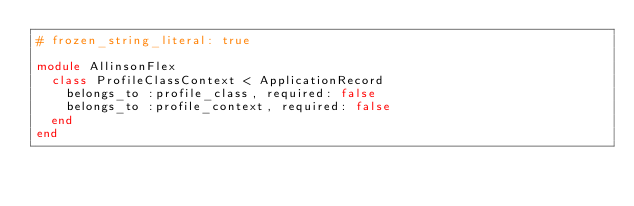Convert code to text. <code><loc_0><loc_0><loc_500><loc_500><_Ruby_># frozen_string_literal: true

module AllinsonFlex
  class ProfileClassContext < ApplicationRecord
    belongs_to :profile_class, required: false
    belongs_to :profile_context, required: false
  end
end
</code> 